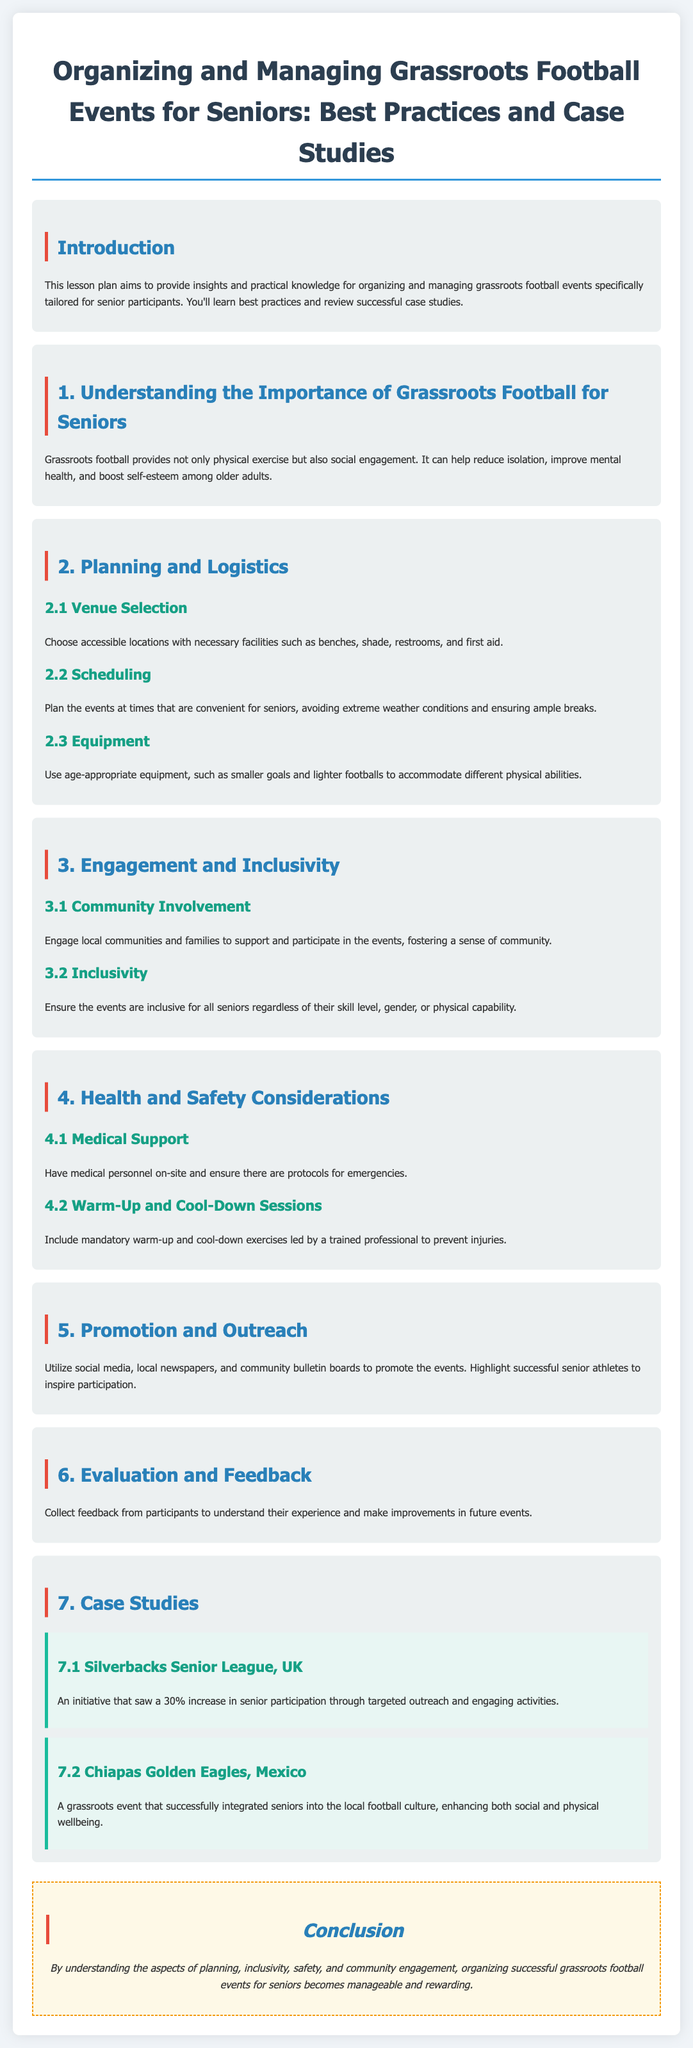What is the main focus of the lesson plan? The lesson plan mainly focuses on organizing and managing grassroots football events for senior participants.
Answer: grassroots football events for seniors What is one benefit of grassroots football for seniors mentioned in the document? The document states that grassroots football helps reduce isolation among older adults.
Answer: reduce isolation What percentage increase in senior participation did the Silverbacks Senior League achieve? The Silverbacks Senior League saw a 30% increase in senior participation through targeted outreach.
Answer: 30% What is one key health consideration included in the event planning? The document highlights the importance of including mandatory warm-up and cool-down exercises led by a trained professional.
Answer: warm-up and cool-down exercises What is suggested for promoting grassroots football events? The document suggests utilizing social media, local newspapers, and community bulletin boards to promote the events.
Answer: social media, local newspapers, community bulletin boards Which country is associated with the Chiapas Golden Eagles case study? The Chiapas Golden Eagles case study is associated with Mexico.
Answer: Mexico Why is community involvement emphasized in the document? Community involvement is emphasized to foster a sense of community and support for participating seniors.
Answer: sense of community What type of venues should be selected for events? Select accessible locations with necessary facilities such as benches, shade, and restrooms.
Answer: accessible locations 